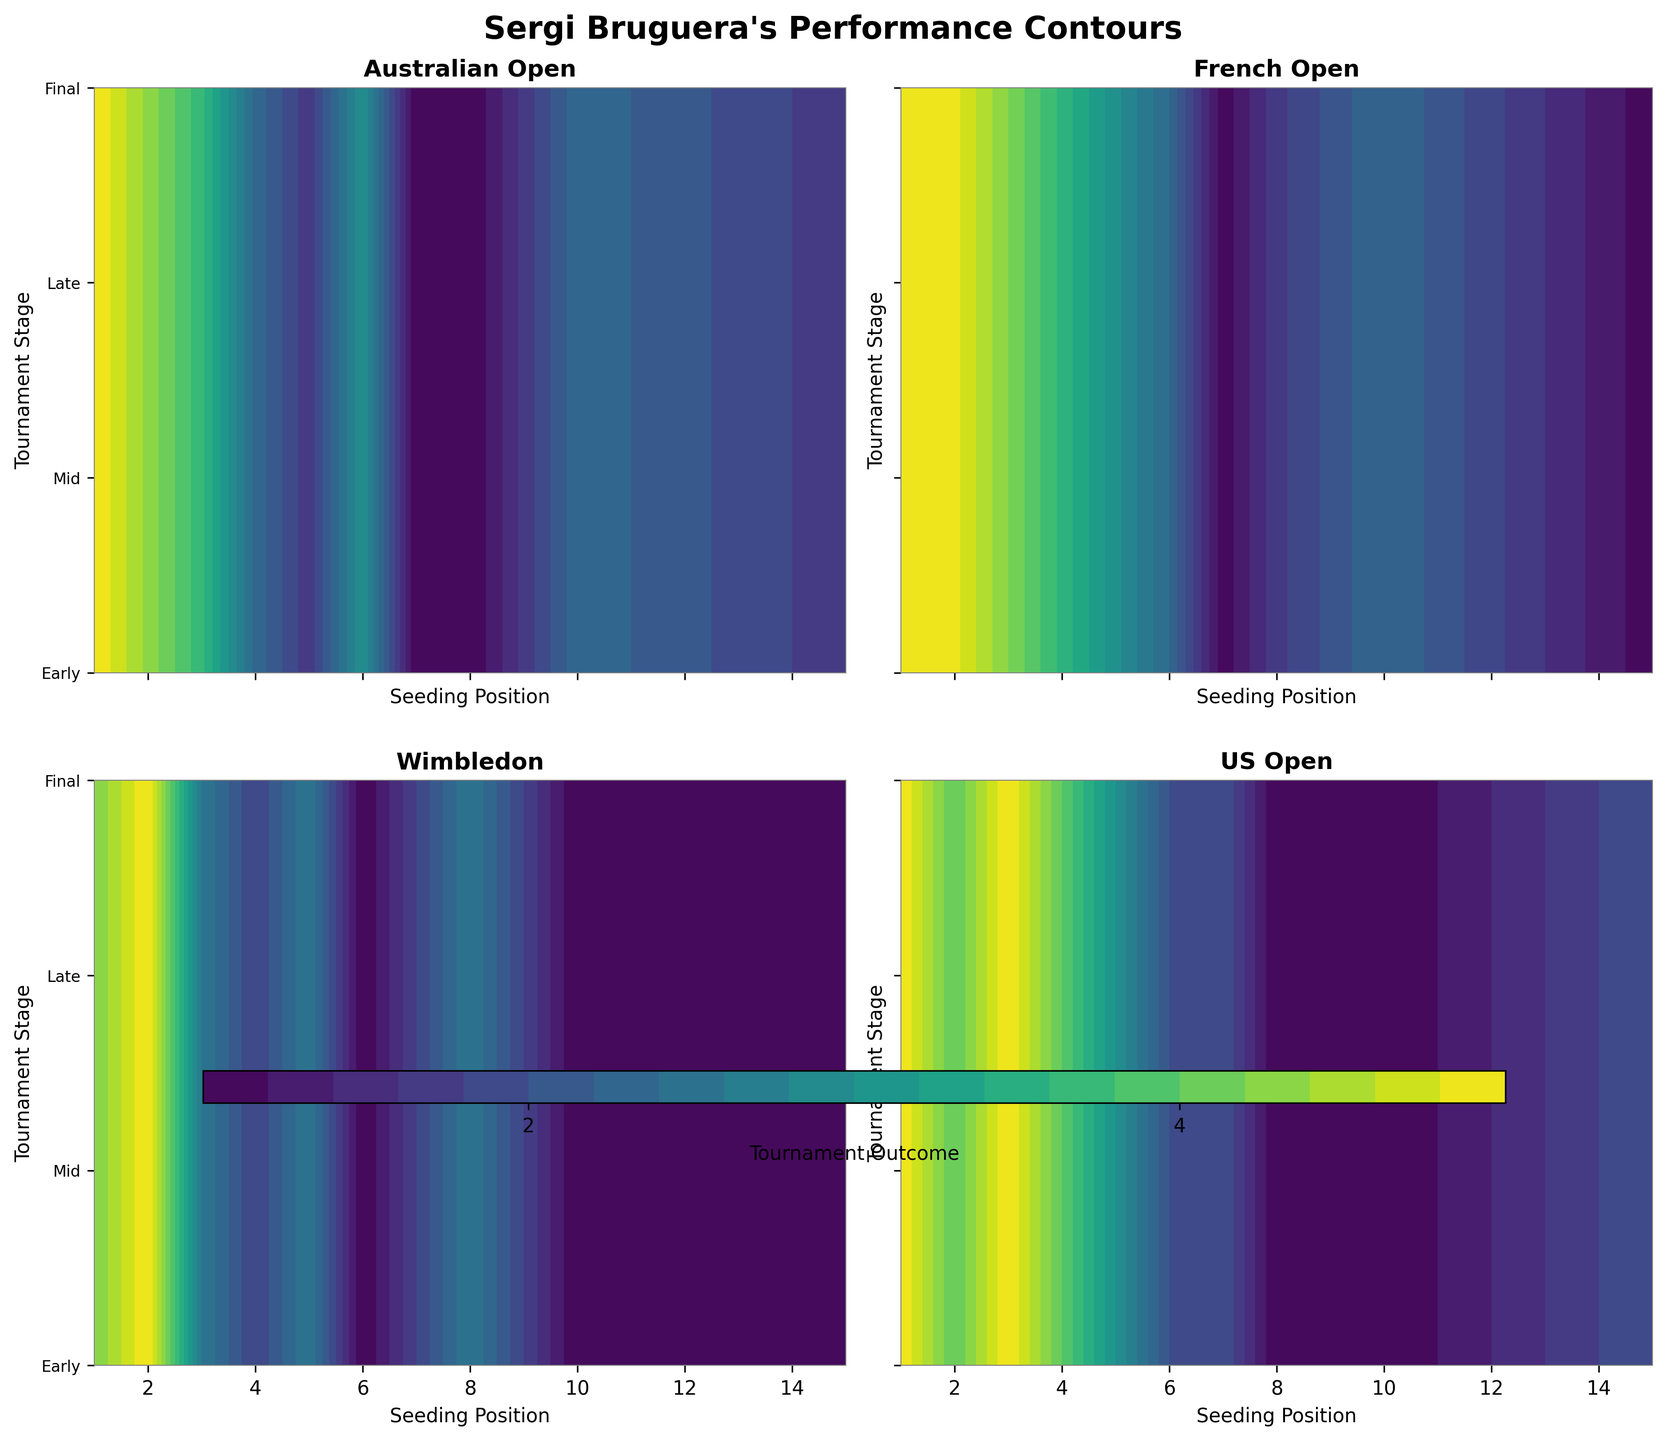Is the contour plot for each Grand Slam tournament labeled? Yes, each of the four subplots (Australian Open, French Open, Wimbledon, and US Open) is labeled with the respective tournament name in the title section of each subplot.
Answer: Yes Which Grand Slam does Sergi Bruguera perform the best in based on the contours? The contour for the French Open shows the highest values (represented by the darkest colors) for his seeding positions, indicating his best performance among the tournaments.
Answer: French Open What do the axes for each subplot represent? The x-axis represents the seeding positions, and the y-axis represents the tournament stages categorized as Early, Mid, Late, and Final.
Answer: Seeding and Tournament Stage At which Grand Slam does Sergi Bruguera perform the worst when seeded 8? The darkest contour colors, indicating poor performance (Early stages), appear in the Australian Open subplot when Sergi Bruguera is seeded 8.
Answer: Australian Open How does Sergi Bruguera's seeding position affect his performance at Wimbledon? Sergi Bruguera's performance at Wimbledon correlates inversely with his seeding position; as his seeding improves (lower number), his performance is better (darker colors towards the 'Late' and 'Final' stages).
Answer: Inversely Compare the difference in Sergi Bruguera’s performances at the US Open between seeding position 1 and 7. When seeded 1, the darkest colors, representing higher stages (Semi Finals and beyond), dominate the plot, while at seeding 7, the lighter colors, representing earlier stages (Third Round), are more prevalent.
Answer: Better at Seeding 1 If Sergi Bruguera is seeded 3, what is the highest stage he reaches at the French Open? Based on the contours for the French Open, Sergi Bruguera reaches the Final stage (dark color near final y-axis value) when seeded 3.
Answer: Final What pattern can you observe about Sergi Bruguera’s seeding and performance in the Australian Open and US Open compared to the French Open? In the French Open, higher seeds (lower numbers) correlate strongly with reaching later stages, unlike the Australian and US Opens where the performance is more varied and inconsistent.
Answer: Consistency in French, Varied in Australian and US Which Grand Slam shows the least correlation between seeding position and tournament outcome for Sergi Bruguera? The Australian Open subplot shows the least correlation since the colors indicating performance stages are more scattered and inconsistent across different seeding positions compared to other tournaments.
Answer: Australian Open 